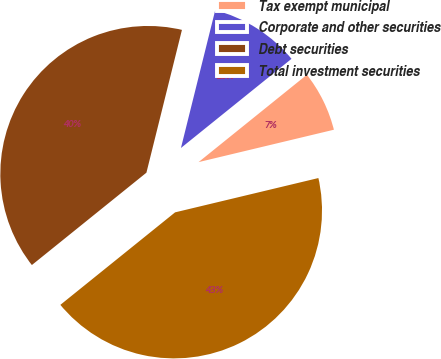<chart> <loc_0><loc_0><loc_500><loc_500><pie_chart><fcel>Tax exempt municipal<fcel>Corporate and other securities<fcel>Debt securities<fcel>Total investment securities<nl><fcel>7.06%<fcel>10.32%<fcel>39.68%<fcel>42.94%<nl></chart> 